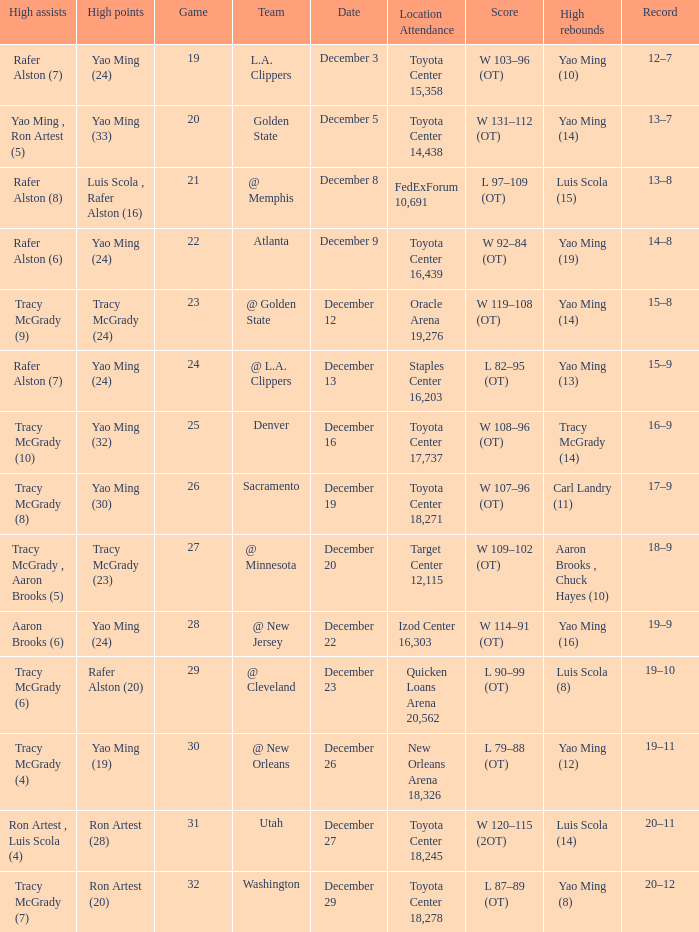When aaron brooks (6) had the highest amount of assists what is the date? December 22. 